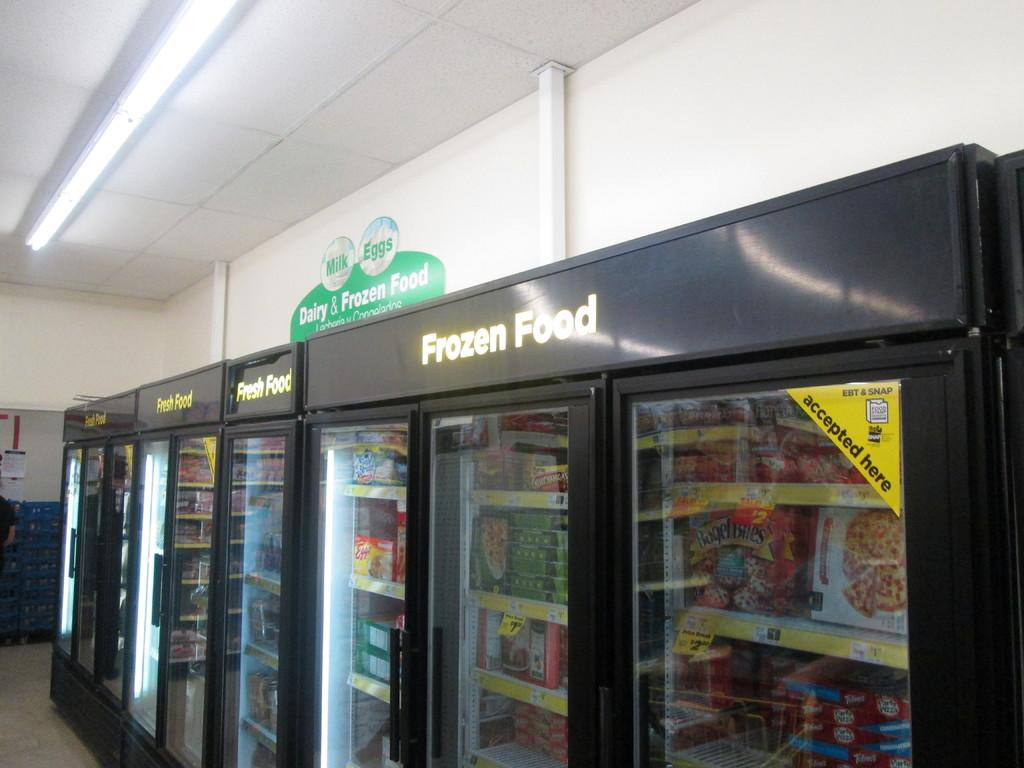<image>
Provide a brief description of the given image. Section in a grocery store for Frozen foods. 